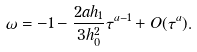Convert formula to latex. <formula><loc_0><loc_0><loc_500><loc_500>\omega = - 1 - \frac { 2 a h _ { 1 } } { 3 h _ { 0 } ^ { 2 } } \tau ^ { a - 1 } + O ( \tau ^ { a } ) .</formula> 